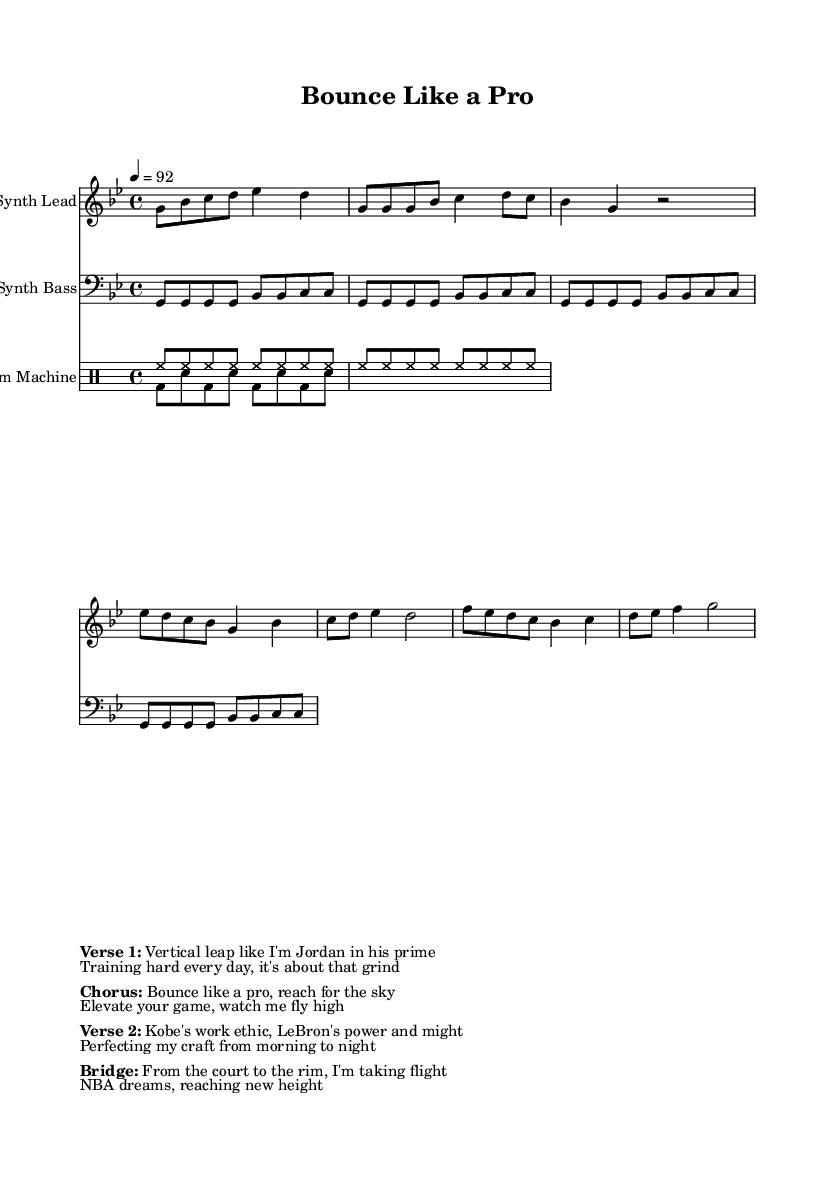What is the key signature of this music? The key signature is G minor, which has two flats (B and E). This can be identified by looking at the key signature notation at the beginning of the staff.
Answer: G minor What is the time signature of this piece? The time signature is 4/4, indicated near the beginning of the score. This means there are four beats in each measure and the quarter note gets one beat.
Answer: 4/4 What is the tempo marking for the music? The tempo marking is 92 beats per minute, which can be found written above the staff at the start. It indicates how fast the piece should be played.
Answer: 92 What is the title of this piece? The title "Bounce Like a Pro" is located at the top of the sheet music in the header. This informs the listener of the name of the composition.
Answer: Bounce Like a Pro How many measures are in the chorus section? The chorus consists of two measures, which can be counted by locating the chorus indications in the music and counting the measures from the notation provided.
Answer: 2 What basketball player's name is mentioned in the first verse? Michael Jordan's name is mentioned as part of the lyrics within the verse, referencing his vertical leap and skill level. This shows the connection to basketball within the song.
Answer: Jordan What theme is predominant in the lyrics of this piece? The predominant theme is "basketball training and aspiration," as expressed in the lyrics emphasizing hard work, elevation, and achieving NBA dreams through dedication.
Answer: Basketball training and aspiration 